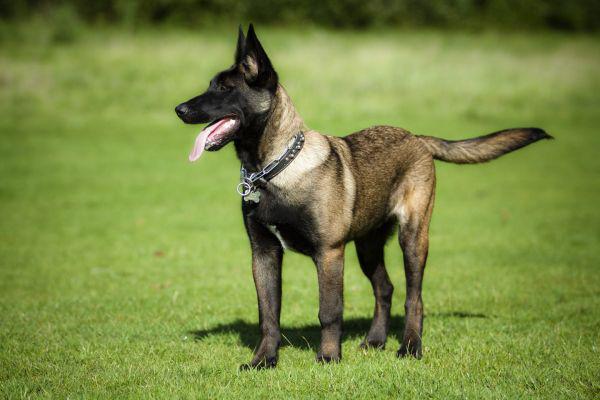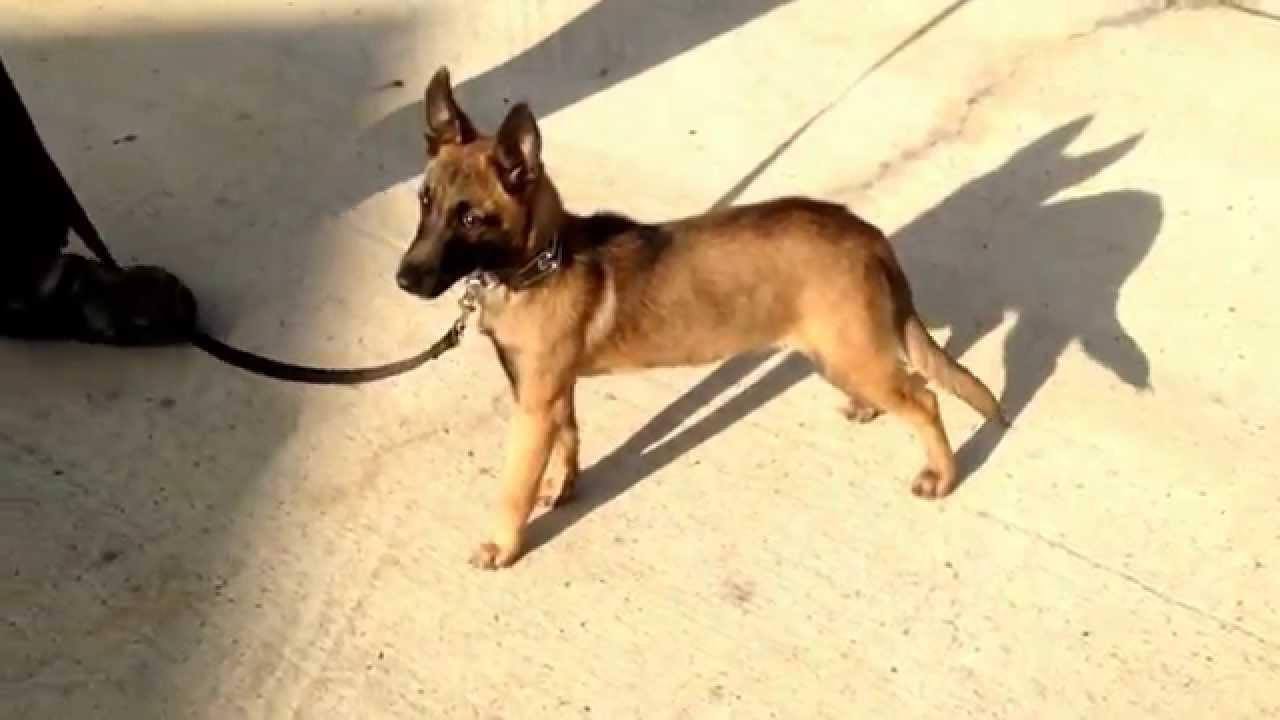The first image is the image on the left, the second image is the image on the right. Evaluate the accuracy of this statement regarding the images: "A german shepherd wearing a collar without a leash stands on the grass on all fours, with its tail nearly parallel to the ground.". Is it true? Answer yes or no. Yes. The first image is the image on the left, the second image is the image on the right. Examine the images to the left and right. Is the description "One dog is on a leash, while a second dog is not, but is wearing a collar and is standing on grass with its tongue out and tail outstretched." accurate? Answer yes or no. Yes. 